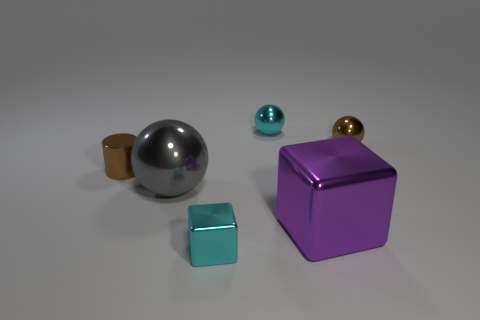Does the small shiny block that is right of the large gray metallic sphere have the same color as the cube that is behind the cyan metallic block?
Give a very brief answer. No. What number of other things are there of the same shape as the purple object?
Give a very brief answer. 1. Are there an equal number of brown metal cylinders to the left of the purple object and cyan blocks that are behind the big metallic ball?
Give a very brief answer. No. Do the brown object that is to the left of the brown ball and the cyan thing in front of the large shiny sphere have the same material?
Make the answer very short. Yes. How many other things are the same size as the brown ball?
Provide a succinct answer. 3. What number of things are either big things or brown objects that are to the left of the small metal block?
Keep it short and to the point. 3. Are there the same number of gray things that are on the right side of the large purple metallic thing and blue cubes?
Provide a succinct answer. Yes. What shape is the gray thing that is made of the same material as the cyan cube?
Provide a short and direct response. Sphere. Is there a rubber thing that has the same color as the cylinder?
Your answer should be very brief. No. How many rubber things are either big blocks or large gray spheres?
Offer a very short reply. 0. 